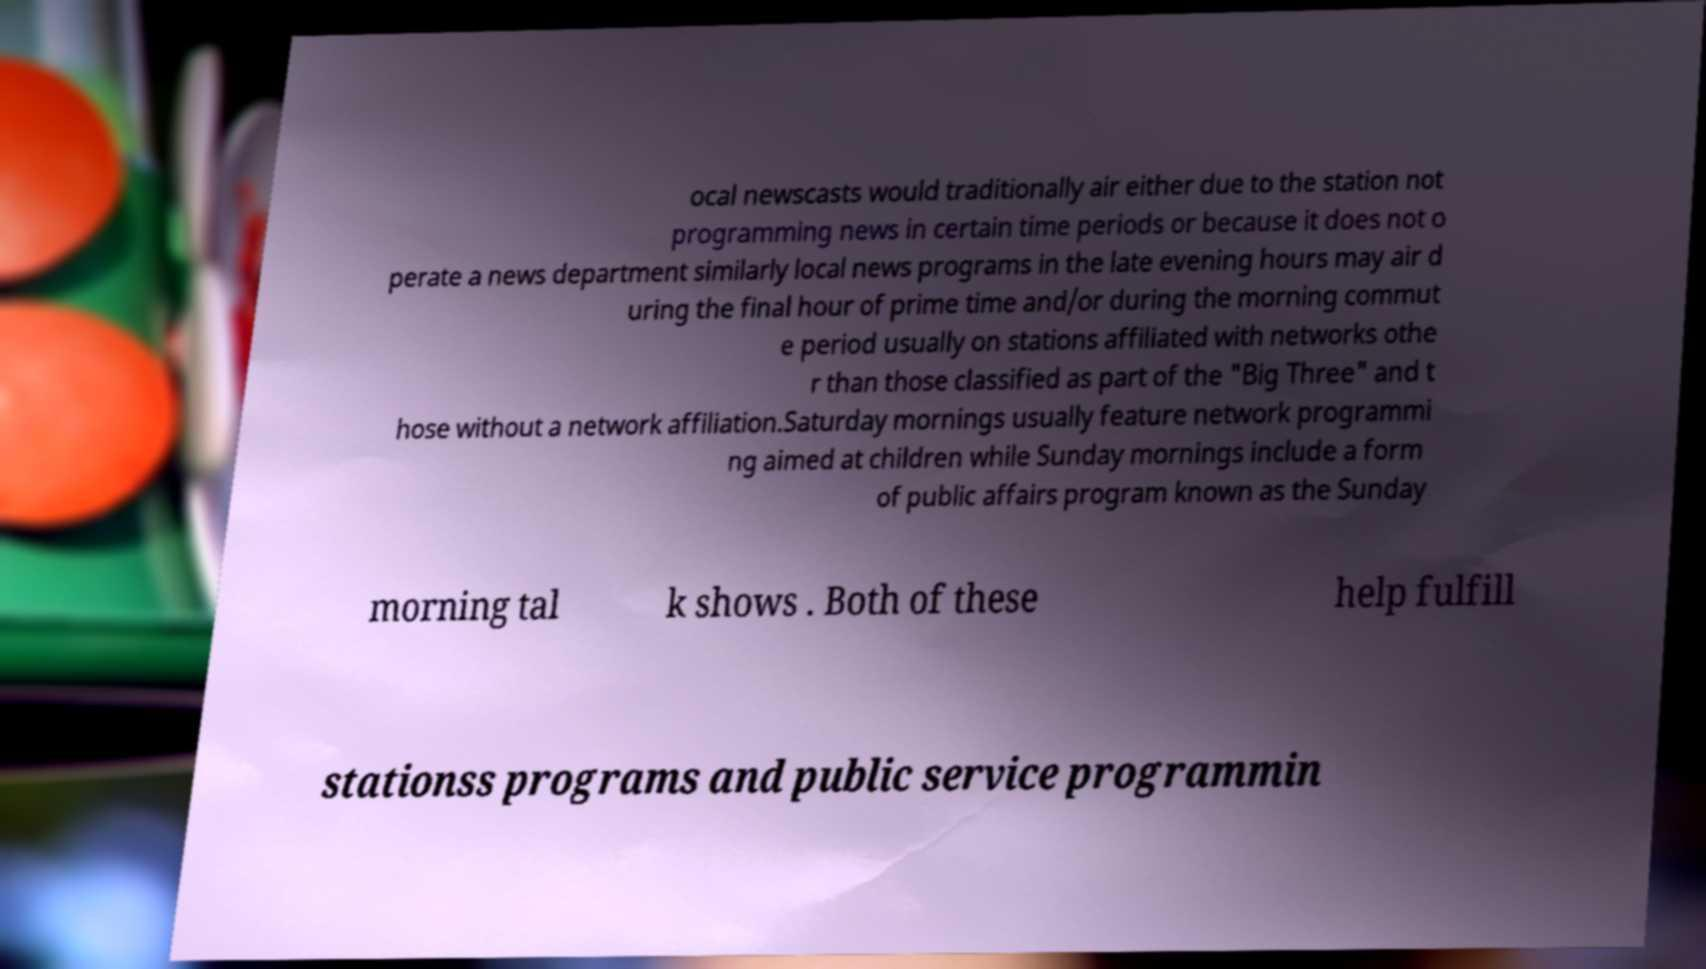Could you assist in decoding the text presented in this image and type it out clearly? ocal newscasts would traditionally air either due to the station not programming news in certain time periods or because it does not o perate a news department similarly local news programs in the late evening hours may air d uring the final hour of prime time and/or during the morning commut e period usually on stations affiliated with networks othe r than those classified as part of the "Big Three" and t hose without a network affiliation.Saturday mornings usually feature network programmi ng aimed at children while Sunday mornings include a form of public affairs program known as the Sunday morning tal k shows . Both of these help fulfill stationss programs and public service programmin 